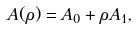<formula> <loc_0><loc_0><loc_500><loc_500>A ( \rho ) = A _ { 0 } + \rho A _ { 1 } ,</formula> 